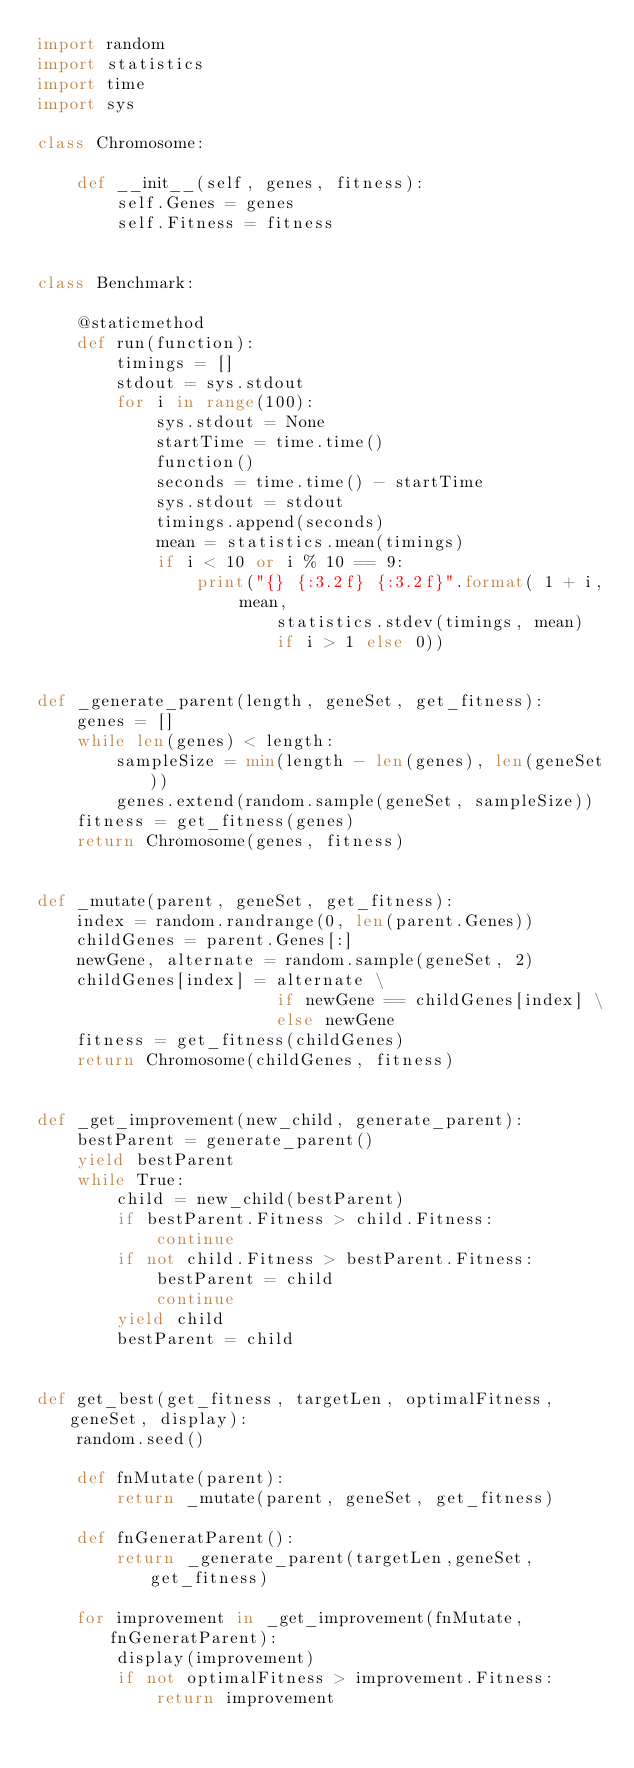<code> <loc_0><loc_0><loc_500><loc_500><_Python_>import random
import statistics
import time
import sys

class Chromosome:
    
    def __init__(self, genes, fitness):
        self.Genes = genes
        self.Fitness = fitness


class Benchmark:

    @staticmethod
    def run(function):
        timings = []
        stdout = sys.stdout
        for i in range(100):
            sys.stdout = None
            startTime = time.time()
            function()
            seconds = time.time() - startTime 
            sys.stdout = stdout
            timings.append(seconds)
            mean = statistics.mean(timings)
            if i < 10 or i % 10 == 9:
                print("{} {:3.2f} {:3.2f}".format( 1 + i, mean,
                        statistics.stdev(timings, mean) 
                        if i > 1 else 0)) 


def _generate_parent(length, geneSet, get_fitness): 
    genes = []
    while len(genes) < length:
        sampleSize = min(length - len(genes), len(geneSet)) 
        genes.extend(random.sample(geneSet, sampleSize))
    fitness = get_fitness(genes)
    return Chromosome(genes, fitness)


def _mutate(parent, geneSet, get_fitness):
    index = random.randrange(0, len(parent.Genes)) 
    childGenes = parent.Genes[:]
    newGene, alternate = random.sample(geneSet, 2) 
    childGenes[index] = alternate \
                        if newGene == childGenes[index] \
                        else newGene
    fitness = get_fitness(childGenes)
    return Chromosome(childGenes, fitness)


def _get_improvement(new_child, generate_parent):
    bestParent = generate_parent()
    yield bestParent
    while True:
        child = new_child(bestParent)
        if bestParent.Fitness > child.Fitness:
            continue
        if not child.Fitness > bestParent.Fitness:
            bestParent = child
            continue
        yield child
        bestParent = child


def get_best(get_fitness, targetLen, optimalFitness, geneSet, display): 
    random.seed()

    def fnMutate(parent):
        return _mutate(parent, geneSet, get_fitness)
    
    def fnGeneratParent():
        return _generate_parent(targetLen,geneSet,get_fitness)

    for improvement in _get_improvement(fnMutate, fnGeneratParent):
        display(improvement)
        if not optimalFitness > improvement.Fitness:
            return improvement</code> 